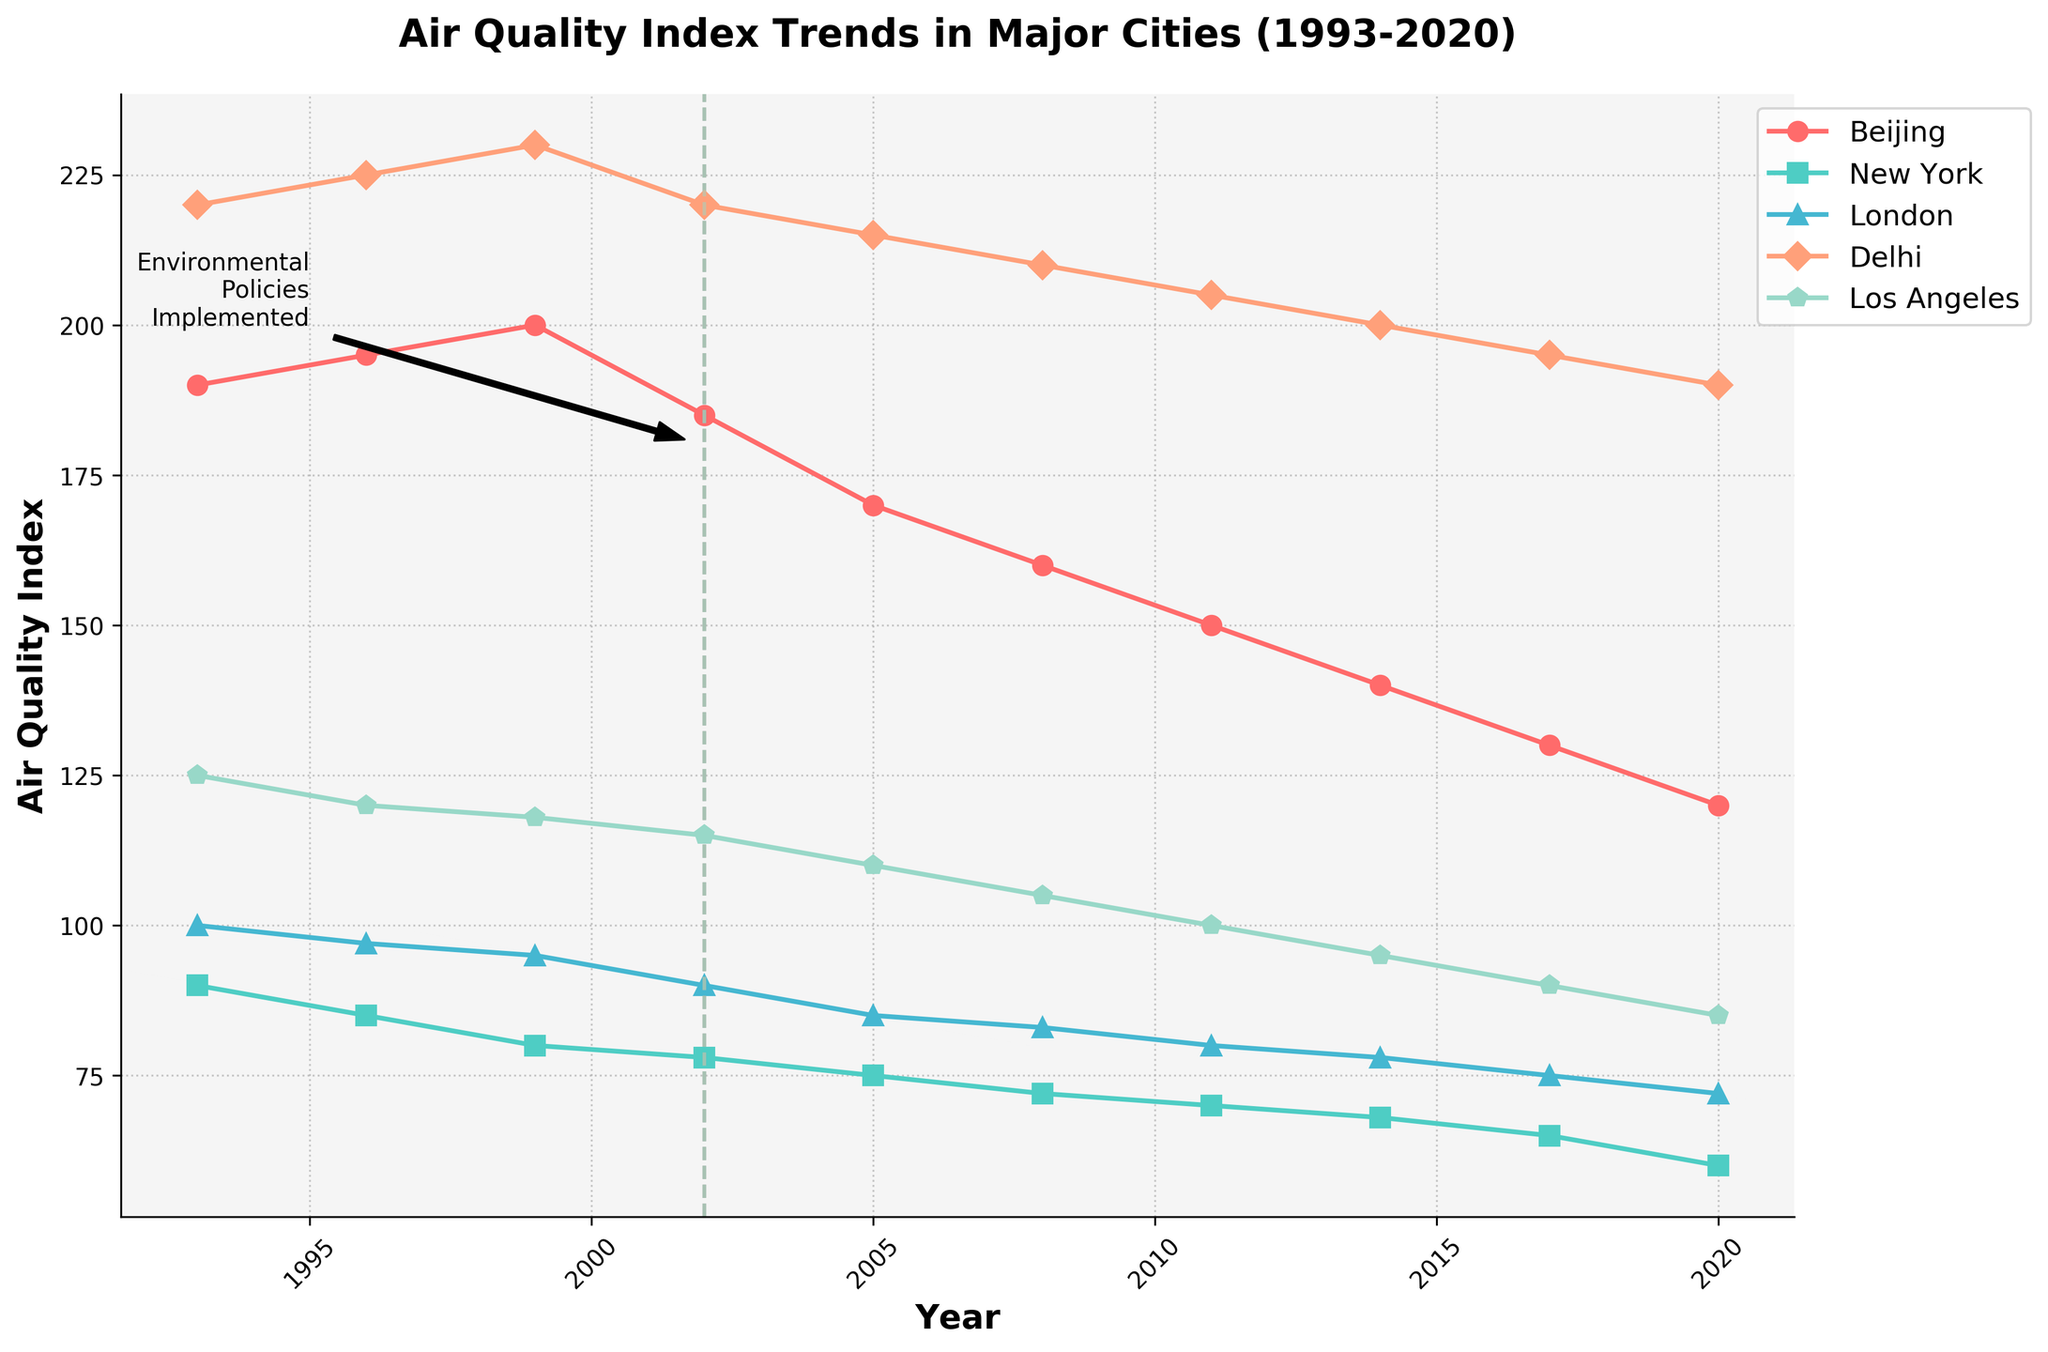What is the title of the plot? The title is displayed at the top of the plot. It is located centrally above the graph area in a bold font.
Answer: Air Quality Index Trends in Major Cities (1993-2020) Which city had the highest Air Quality Index in 1999? In 1999, visually inspect the lines to see which city reaches the highest point on the y-axis. The highest point in 1999 is Delhi.
Answer: Delhi Did Beijing's air quality improve or worsen after implementing environmental policies in 2002? Find the year 2002 and examine the trend of Beijing's line from that point onward. Beijing's line moves downward, indicating improvement.
Answer: Improve Compare the Air Quality Index of New York and London in 2005. Which city had better air quality? Look at the data points for New York and London in 2005. New York's dot is at 75 while London's dot is at 85. Lower Air Quality Index means better air quality.
Answer: New York What is the general trend of air quality in Los Angeles over the years? Follow Los Angeles' line from 1993 to 2020. The trend shows a decrease in the Air Quality Index, indicating improvement over the years.
Answer: Improvement How many years did it take for Delhi's Air Quality Index to drop to 195 after implementing the policy? Find the year when the policy was implemented (2002) and then check the year when the Air Quality Index reached 195 (2017). Calculate the difference in years.
Answer: 15 years Which city had the lowest Air Quality Index in 2020, and what was the value? Check the data points in 2020 across all cities. New York's line is at the lowest point, with a value of 60.
Answer: New York, 60 How does the trend of air quality change after 2002 compare between Beijing and Los Angeles? Examine the lines for Beijing and Los Angeles from 2002 onward. Both lines show a downward trend, indicating improving air quality, but Beijing's rate of decline is steeper.
Answer: Both improved; Beijing improved faster What is the color and marker style used for Delhi? Look at the line representing Delhi and note its visual properties. Delhi's line is marked in green with triangle markers.
Answer: Green, triangle Identify one possible interpretation for the vertical dashed lines in the plot. The vertical dashed lines appear at the year environmental policies were implemented in each city, indicating the beginning of policy impact.
Answer: Policy implementation year 